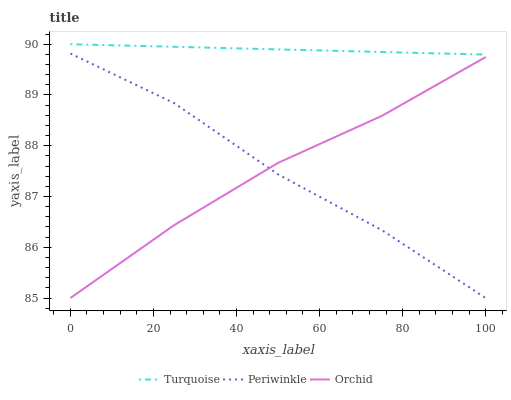Does Periwinkle have the minimum area under the curve?
Answer yes or no. Yes. Does Turquoise have the maximum area under the curve?
Answer yes or no. Yes. Does Orchid have the minimum area under the curve?
Answer yes or no. No. Does Orchid have the maximum area under the curve?
Answer yes or no. No. Is Turquoise the smoothest?
Answer yes or no. Yes. Is Periwinkle the roughest?
Answer yes or no. Yes. Is Orchid the smoothest?
Answer yes or no. No. Is Orchid the roughest?
Answer yes or no. No. Does Periwinkle have the lowest value?
Answer yes or no. Yes. Does Turquoise have the highest value?
Answer yes or no. Yes. Does Periwinkle have the highest value?
Answer yes or no. No. Is Orchid less than Turquoise?
Answer yes or no. Yes. Is Turquoise greater than Periwinkle?
Answer yes or no. Yes. Does Periwinkle intersect Orchid?
Answer yes or no. Yes. Is Periwinkle less than Orchid?
Answer yes or no. No. Is Periwinkle greater than Orchid?
Answer yes or no. No. Does Orchid intersect Turquoise?
Answer yes or no. No. 